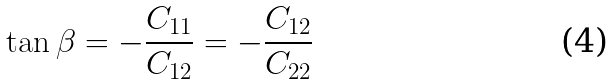<formula> <loc_0><loc_0><loc_500><loc_500>\tan \beta = - \frac { C _ { 1 1 } } { C _ { 1 2 } } = - \frac { C _ { 1 2 } } { C _ { 2 2 } }</formula> 